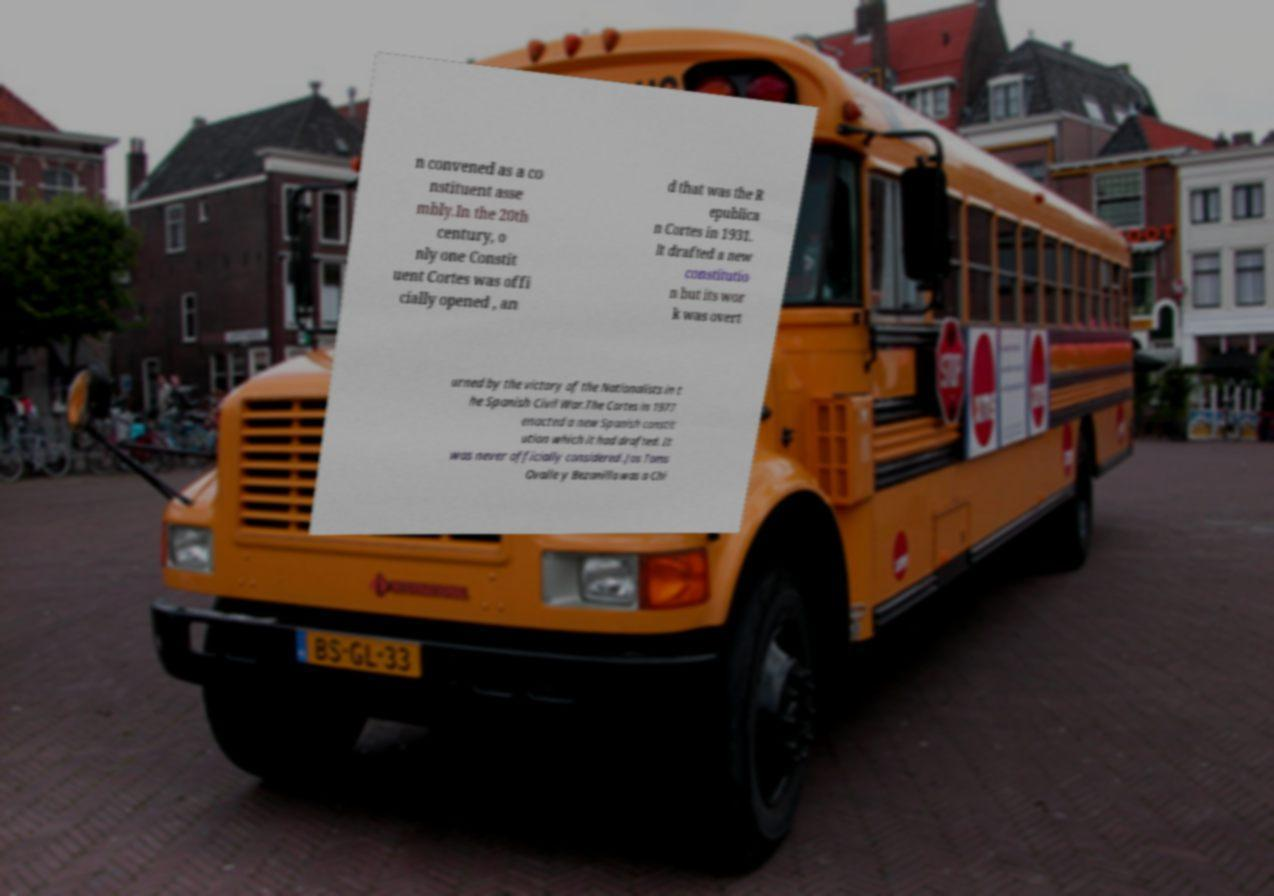Could you extract and type out the text from this image? n convened as a co nstituent asse mbly.In the 20th century, o nly one Constit uent Cortes was offi cially opened , an d that was the R epublica n Cortes in 1931. It drafted a new constitutio n but its wor k was overt urned by the victory of the Nationalists in t he Spanish Civil War.The Cortes in 1977 enacted a new Spanish constit ution which it had drafted. It was never officially considered .Jos Toms Ovalle y Bezanilla was a Chi 